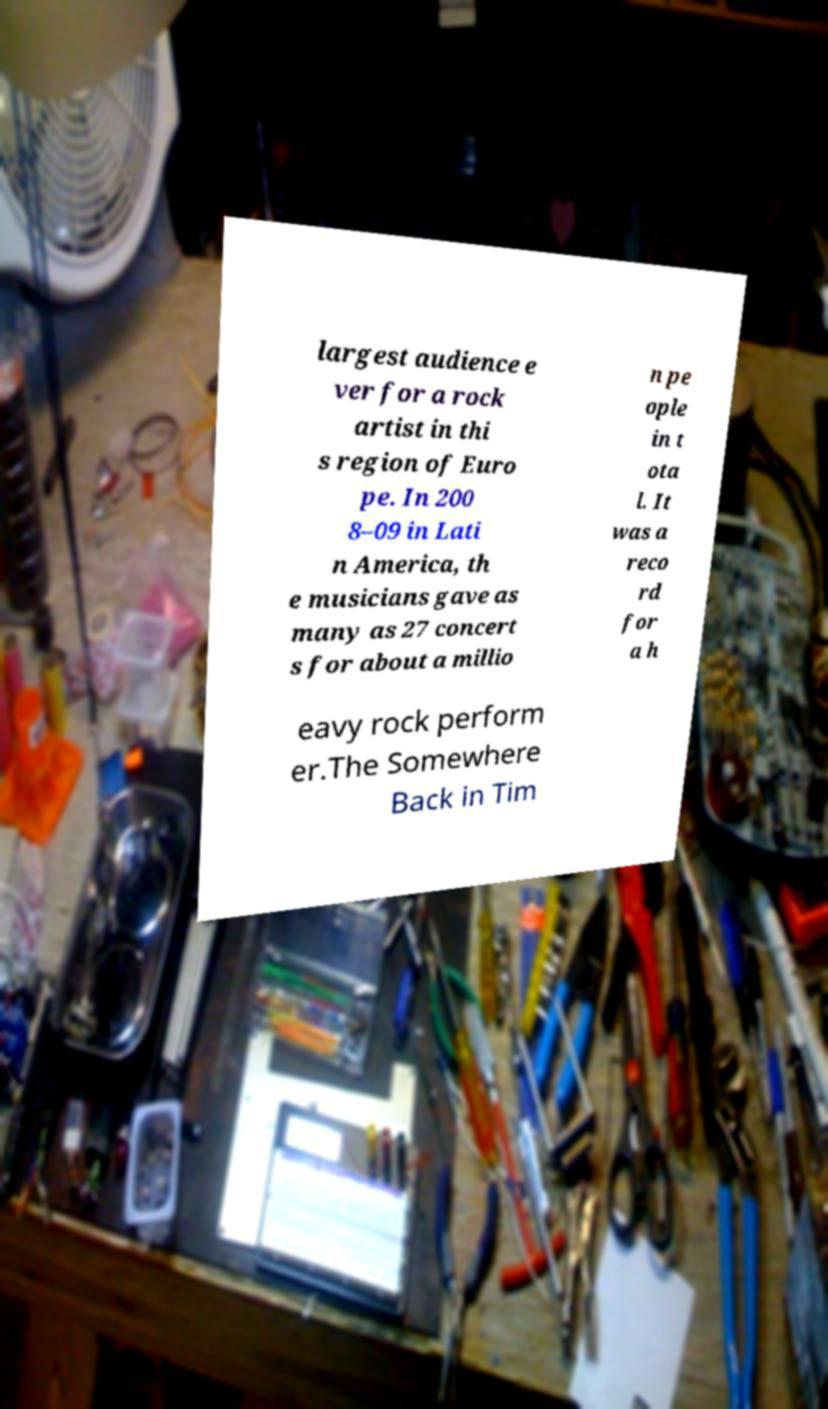Could you extract and type out the text from this image? largest audience e ver for a rock artist in thi s region of Euro pe. In 200 8–09 in Lati n America, th e musicians gave as many as 27 concert s for about a millio n pe ople in t ota l. It was a reco rd for a h eavy rock perform er.The Somewhere Back in Tim 